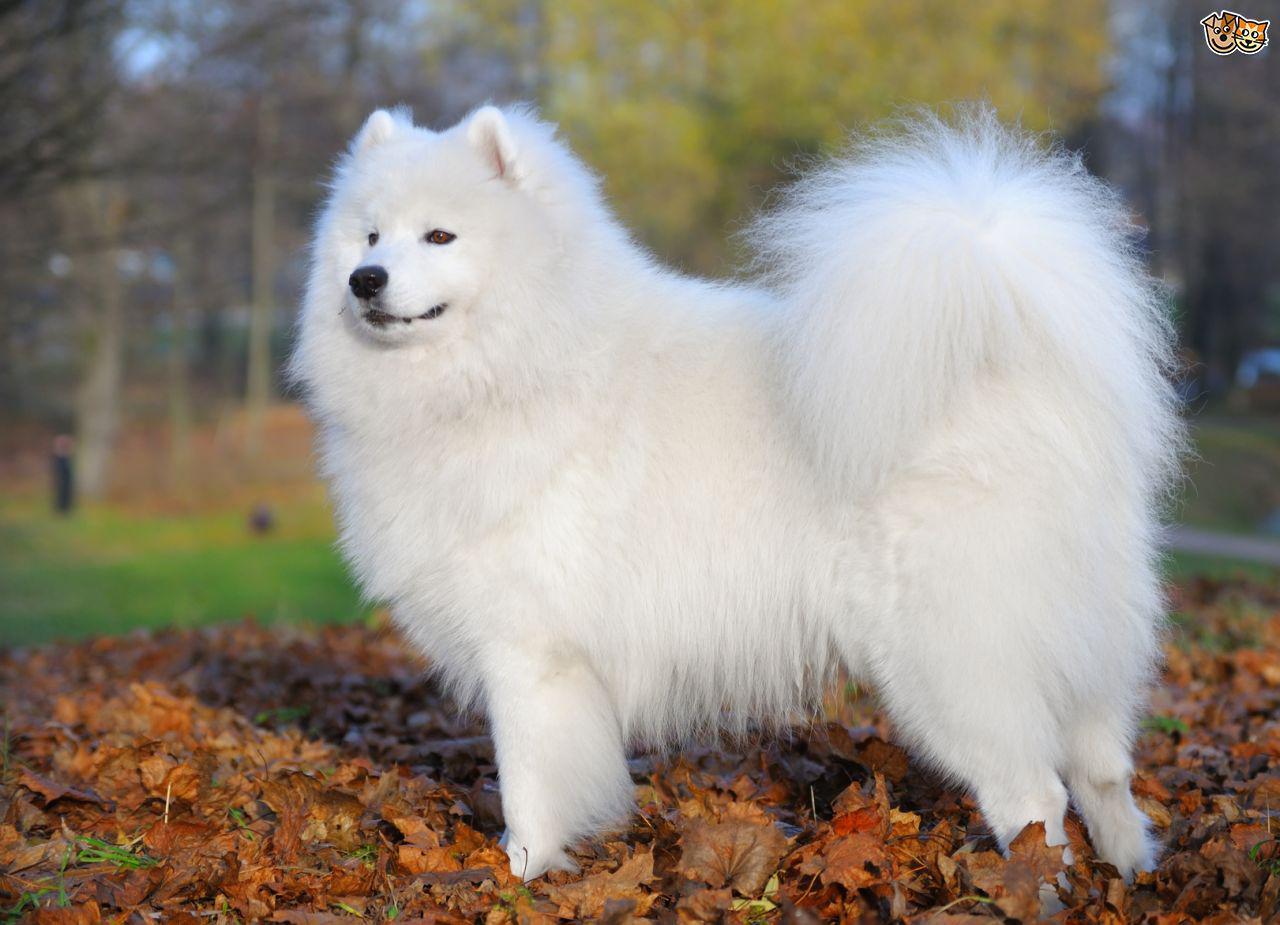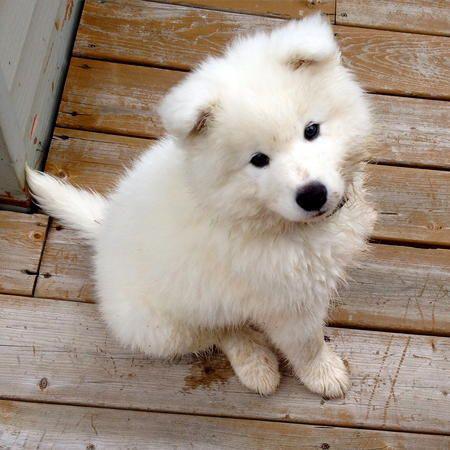The first image is the image on the left, the second image is the image on the right. Assess this claim about the two images: "A person is posing with a white dog.". Correct or not? Answer yes or no. No. The first image is the image on the left, the second image is the image on the right. Assess this claim about the two images: "At least one image shows a person next to a big white dog.". Correct or not? Answer yes or no. No. 